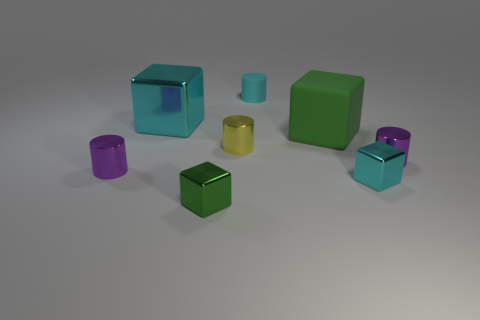There is a green matte cube; is it the same size as the matte thing that is left of the green rubber cube?
Offer a very short reply. No. There is a large matte object that is behind the green cube that is in front of the tiny yellow metal object; what number of green blocks are right of it?
Offer a very short reply. 0. The cylinder that is the same color as the big metallic object is what size?
Provide a succinct answer. Small. There is a big green block; are there any green metal blocks to the right of it?
Your answer should be very brief. No. What is the shape of the big cyan object?
Give a very brief answer. Cube. There is a purple shiny object in front of the shiny object to the right of the shiny block on the right side of the yellow shiny cylinder; what is its shape?
Your response must be concise. Cylinder. How many other things are there of the same shape as the small cyan rubber object?
Your answer should be compact. 3. There is a tiny block that is right of the green block that is to the right of the yellow object; what is its material?
Keep it short and to the point. Metal. Is there anything else that has the same size as the green metallic block?
Ensure brevity in your answer.  Yes. Do the large cyan thing and the tiny purple cylinder to the left of the yellow cylinder have the same material?
Your answer should be very brief. Yes. 